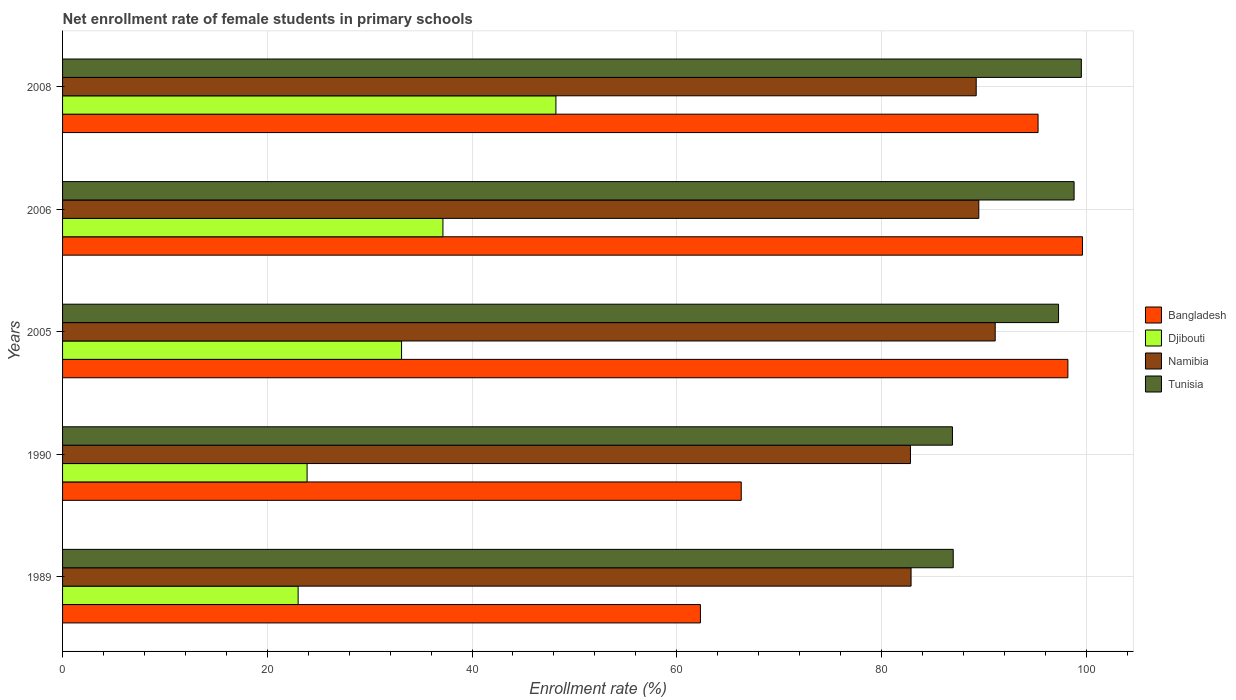How many different coloured bars are there?
Your answer should be very brief. 4. How many groups of bars are there?
Give a very brief answer. 5. Are the number of bars per tick equal to the number of legend labels?
Offer a very short reply. Yes. How many bars are there on the 4th tick from the bottom?
Give a very brief answer. 4. What is the net enrollment rate of female students in primary schools in Namibia in 2005?
Provide a succinct answer. 91.11. Across all years, what is the maximum net enrollment rate of female students in primary schools in Bangladesh?
Offer a terse response. 99.63. Across all years, what is the minimum net enrollment rate of female students in primary schools in Djibouti?
Provide a short and direct response. 23.01. What is the total net enrollment rate of female students in primary schools in Bangladesh in the graph?
Your answer should be compact. 421.75. What is the difference between the net enrollment rate of female students in primary schools in Djibouti in 1989 and that in 1990?
Offer a very short reply. -0.88. What is the difference between the net enrollment rate of female students in primary schools in Bangladesh in 2005 and the net enrollment rate of female students in primary schools in Namibia in 1989?
Keep it short and to the point. 15.32. What is the average net enrollment rate of female students in primary schools in Djibouti per year?
Your answer should be very brief. 33.07. In the year 2006, what is the difference between the net enrollment rate of female students in primary schools in Djibouti and net enrollment rate of female students in primary schools in Namibia?
Your response must be concise. -52.35. What is the ratio of the net enrollment rate of female students in primary schools in Tunisia in 2006 to that in 2008?
Keep it short and to the point. 0.99. What is the difference between the highest and the second highest net enrollment rate of female students in primary schools in Tunisia?
Your answer should be compact. 0.71. What is the difference between the highest and the lowest net enrollment rate of female students in primary schools in Bangladesh?
Make the answer very short. 37.32. In how many years, is the net enrollment rate of female students in primary schools in Djibouti greater than the average net enrollment rate of female students in primary schools in Djibouti taken over all years?
Your answer should be compact. 3. What does the 2nd bar from the top in 2006 represents?
Ensure brevity in your answer.  Namibia. What does the 2nd bar from the bottom in 2005 represents?
Give a very brief answer. Djibouti. Is it the case that in every year, the sum of the net enrollment rate of female students in primary schools in Namibia and net enrollment rate of female students in primary schools in Tunisia is greater than the net enrollment rate of female students in primary schools in Bangladesh?
Your response must be concise. Yes. Are all the bars in the graph horizontal?
Your answer should be compact. Yes. What is the difference between two consecutive major ticks on the X-axis?
Provide a succinct answer. 20. Does the graph contain grids?
Offer a very short reply. Yes. Where does the legend appear in the graph?
Your response must be concise. Center right. How are the legend labels stacked?
Give a very brief answer. Vertical. What is the title of the graph?
Provide a short and direct response. Net enrollment rate of female students in primary schools. Does "Angola" appear as one of the legend labels in the graph?
Ensure brevity in your answer.  No. What is the label or title of the X-axis?
Keep it short and to the point. Enrollment rate (%). What is the Enrollment rate (%) of Bangladesh in 1989?
Provide a succinct answer. 62.31. What is the Enrollment rate (%) of Djibouti in 1989?
Your answer should be compact. 23.01. What is the Enrollment rate (%) in Namibia in 1989?
Your answer should be very brief. 82.89. What is the Enrollment rate (%) in Tunisia in 1989?
Make the answer very short. 87.01. What is the Enrollment rate (%) of Bangladesh in 1990?
Offer a very short reply. 66.3. What is the Enrollment rate (%) of Djibouti in 1990?
Ensure brevity in your answer.  23.89. What is the Enrollment rate (%) in Namibia in 1990?
Provide a short and direct response. 82.83. What is the Enrollment rate (%) of Tunisia in 1990?
Offer a very short reply. 86.93. What is the Enrollment rate (%) in Bangladesh in 2005?
Give a very brief answer. 98.21. What is the Enrollment rate (%) of Djibouti in 2005?
Offer a very short reply. 33.12. What is the Enrollment rate (%) in Namibia in 2005?
Your answer should be very brief. 91.11. What is the Enrollment rate (%) of Tunisia in 2005?
Ensure brevity in your answer.  97.3. What is the Enrollment rate (%) of Bangladesh in 2006?
Keep it short and to the point. 99.63. What is the Enrollment rate (%) in Djibouti in 2006?
Your answer should be compact. 37.16. What is the Enrollment rate (%) in Namibia in 2006?
Make the answer very short. 89.51. What is the Enrollment rate (%) of Tunisia in 2006?
Your response must be concise. 98.81. What is the Enrollment rate (%) of Bangladesh in 2008?
Your answer should be compact. 95.29. What is the Enrollment rate (%) of Djibouti in 2008?
Your answer should be compact. 48.19. What is the Enrollment rate (%) in Namibia in 2008?
Your answer should be very brief. 89.25. What is the Enrollment rate (%) of Tunisia in 2008?
Your answer should be compact. 99.52. Across all years, what is the maximum Enrollment rate (%) of Bangladesh?
Keep it short and to the point. 99.63. Across all years, what is the maximum Enrollment rate (%) in Djibouti?
Give a very brief answer. 48.19. Across all years, what is the maximum Enrollment rate (%) in Namibia?
Your answer should be compact. 91.11. Across all years, what is the maximum Enrollment rate (%) in Tunisia?
Keep it short and to the point. 99.52. Across all years, what is the minimum Enrollment rate (%) of Bangladesh?
Your response must be concise. 62.31. Across all years, what is the minimum Enrollment rate (%) in Djibouti?
Ensure brevity in your answer.  23.01. Across all years, what is the minimum Enrollment rate (%) in Namibia?
Your answer should be compact. 82.83. Across all years, what is the minimum Enrollment rate (%) of Tunisia?
Your response must be concise. 86.93. What is the total Enrollment rate (%) in Bangladesh in the graph?
Keep it short and to the point. 421.75. What is the total Enrollment rate (%) in Djibouti in the graph?
Offer a terse response. 165.37. What is the total Enrollment rate (%) in Namibia in the graph?
Offer a terse response. 435.58. What is the total Enrollment rate (%) in Tunisia in the graph?
Ensure brevity in your answer.  469.57. What is the difference between the Enrollment rate (%) in Bangladesh in 1989 and that in 1990?
Your answer should be compact. -3.99. What is the difference between the Enrollment rate (%) in Djibouti in 1989 and that in 1990?
Your answer should be compact. -0.88. What is the difference between the Enrollment rate (%) of Namibia in 1989 and that in 1990?
Your answer should be compact. 0.06. What is the difference between the Enrollment rate (%) of Tunisia in 1989 and that in 1990?
Your answer should be compact. 0.08. What is the difference between the Enrollment rate (%) in Bangladesh in 1989 and that in 2005?
Provide a short and direct response. -35.9. What is the difference between the Enrollment rate (%) of Djibouti in 1989 and that in 2005?
Provide a succinct answer. -10.1. What is the difference between the Enrollment rate (%) of Namibia in 1989 and that in 2005?
Make the answer very short. -8.22. What is the difference between the Enrollment rate (%) of Tunisia in 1989 and that in 2005?
Make the answer very short. -10.29. What is the difference between the Enrollment rate (%) of Bangladesh in 1989 and that in 2006?
Your answer should be compact. -37.32. What is the difference between the Enrollment rate (%) of Djibouti in 1989 and that in 2006?
Your response must be concise. -14.15. What is the difference between the Enrollment rate (%) in Namibia in 1989 and that in 2006?
Your answer should be compact. -6.62. What is the difference between the Enrollment rate (%) of Tunisia in 1989 and that in 2006?
Offer a very short reply. -11.81. What is the difference between the Enrollment rate (%) in Bangladesh in 1989 and that in 2008?
Provide a succinct answer. -32.98. What is the difference between the Enrollment rate (%) in Djibouti in 1989 and that in 2008?
Provide a short and direct response. -25.18. What is the difference between the Enrollment rate (%) of Namibia in 1989 and that in 2008?
Your answer should be very brief. -6.36. What is the difference between the Enrollment rate (%) in Tunisia in 1989 and that in 2008?
Offer a terse response. -12.52. What is the difference between the Enrollment rate (%) of Bangladesh in 1990 and that in 2005?
Make the answer very short. -31.91. What is the difference between the Enrollment rate (%) of Djibouti in 1990 and that in 2005?
Provide a short and direct response. -9.23. What is the difference between the Enrollment rate (%) in Namibia in 1990 and that in 2005?
Your answer should be very brief. -8.28. What is the difference between the Enrollment rate (%) in Tunisia in 1990 and that in 2005?
Offer a terse response. -10.36. What is the difference between the Enrollment rate (%) of Bangladesh in 1990 and that in 2006?
Make the answer very short. -33.33. What is the difference between the Enrollment rate (%) of Djibouti in 1990 and that in 2006?
Your answer should be compact. -13.27. What is the difference between the Enrollment rate (%) of Namibia in 1990 and that in 2006?
Offer a very short reply. -6.68. What is the difference between the Enrollment rate (%) in Tunisia in 1990 and that in 2006?
Ensure brevity in your answer.  -11.88. What is the difference between the Enrollment rate (%) of Bangladesh in 1990 and that in 2008?
Provide a short and direct response. -28.99. What is the difference between the Enrollment rate (%) in Djibouti in 1990 and that in 2008?
Offer a very short reply. -24.31. What is the difference between the Enrollment rate (%) of Namibia in 1990 and that in 2008?
Give a very brief answer. -6.42. What is the difference between the Enrollment rate (%) in Tunisia in 1990 and that in 2008?
Offer a terse response. -12.59. What is the difference between the Enrollment rate (%) of Bangladesh in 2005 and that in 2006?
Keep it short and to the point. -1.42. What is the difference between the Enrollment rate (%) in Djibouti in 2005 and that in 2006?
Offer a very short reply. -4.04. What is the difference between the Enrollment rate (%) in Namibia in 2005 and that in 2006?
Provide a short and direct response. 1.6. What is the difference between the Enrollment rate (%) in Tunisia in 2005 and that in 2006?
Your answer should be compact. -1.52. What is the difference between the Enrollment rate (%) of Bangladesh in 2005 and that in 2008?
Make the answer very short. 2.92. What is the difference between the Enrollment rate (%) of Djibouti in 2005 and that in 2008?
Provide a short and direct response. -15.08. What is the difference between the Enrollment rate (%) in Namibia in 2005 and that in 2008?
Your answer should be compact. 1.86. What is the difference between the Enrollment rate (%) of Tunisia in 2005 and that in 2008?
Your answer should be very brief. -2.23. What is the difference between the Enrollment rate (%) in Bangladesh in 2006 and that in 2008?
Provide a succinct answer. 4.34. What is the difference between the Enrollment rate (%) of Djibouti in 2006 and that in 2008?
Offer a very short reply. -11.04. What is the difference between the Enrollment rate (%) of Namibia in 2006 and that in 2008?
Your answer should be very brief. 0.25. What is the difference between the Enrollment rate (%) of Tunisia in 2006 and that in 2008?
Make the answer very short. -0.71. What is the difference between the Enrollment rate (%) in Bangladesh in 1989 and the Enrollment rate (%) in Djibouti in 1990?
Offer a very short reply. 38.42. What is the difference between the Enrollment rate (%) in Bangladesh in 1989 and the Enrollment rate (%) in Namibia in 1990?
Your answer should be compact. -20.52. What is the difference between the Enrollment rate (%) of Bangladesh in 1989 and the Enrollment rate (%) of Tunisia in 1990?
Your response must be concise. -24.62. What is the difference between the Enrollment rate (%) of Djibouti in 1989 and the Enrollment rate (%) of Namibia in 1990?
Offer a terse response. -59.82. What is the difference between the Enrollment rate (%) in Djibouti in 1989 and the Enrollment rate (%) in Tunisia in 1990?
Your response must be concise. -63.92. What is the difference between the Enrollment rate (%) of Namibia in 1989 and the Enrollment rate (%) of Tunisia in 1990?
Your response must be concise. -4.04. What is the difference between the Enrollment rate (%) in Bangladesh in 1989 and the Enrollment rate (%) in Djibouti in 2005?
Provide a succinct answer. 29.19. What is the difference between the Enrollment rate (%) of Bangladesh in 1989 and the Enrollment rate (%) of Namibia in 2005?
Offer a very short reply. -28.8. What is the difference between the Enrollment rate (%) in Bangladesh in 1989 and the Enrollment rate (%) in Tunisia in 2005?
Give a very brief answer. -34.98. What is the difference between the Enrollment rate (%) in Djibouti in 1989 and the Enrollment rate (%) in Namibia in 2005?
Offer a very short reply. -68.09. What is the difference between the Enrollment rate (%) in Djibouti in 1989 and the Enrollment rate (%) in Tunisia in 2005?
Your response must be concise. -74.28. What is the difference between the Enrollment rate (%) in Namibia in 1989 and the Enrollment rate (%) in Tunisia in 2005?
Offer a very short reply. -14.41. What is the difference between the Enrollment rate (%) in Bangladesh in 1989 and the Enrollment rate (%) in Djibouti in 2006?
Provide a succinct answer. 25.15. What is the difference between the Enrollment rate (%) of Bangladesh in 1989 and the Enrollment rate (%) of Namibia in 2006?
Your answer should be very brief. -27.2. What is the difference between the Enrollment rate (%) of Bangladesh in 1989 and the Enrollment rate (%) of Tunisia in 2006?
Keep it short and to the point. -36.5. What is the difference between the Enrollment rate (%) of Djibouti in 1989 and the Enrollment rate (%) of Namibia in 2006?
Offer a terse response. -66.49. What is the difference between the Enrollment rate (%) of Djibouti in 1989 and the Enrollment rate (%) of Tunisia in 2006?
Make the answer very short. -75.8. What is the difference between the Enrollment rate (%) in Namibia in 1989 and the Enrollment rate (%) in Tunisia in 2006?
Your response must be concise. -15.93. What is the difference between the Enrollment rate (%) of Bangladesh in 1989 and the Enrollment rate (%) of Djibouti in 2008?
Keep it short and to the point. 14.12. What is the difference between the Enrollment rate (%) of Bangladesh in 1989 and the Enrollment rate (%) of Namibia in 2008?
Your answer should be very brief. -26.94. What is the difference between the Enrollment rate (%) in Bangladesh in 1989 and the Enrollment rate (%) in Tunisia in 2008?
Your answer should be compact. -37.21. What is the difference between the Enrollment rate (%) in Djibouti in 1989 and the Enrollment rate (%) in Namibia in 2008?
Keep it short and to the point. -66.24. What is the difference between the Enrollment rate (%) in Djibouti in 1989 and the Enrollment rate (%) in Tunisia in 2008?
Keep it short and to the point. -76.51. What is the difference between the Enrollment rate (%) of Namibia in 1989 and the Enrollment rate (%) of Tunisia in 2008?
Offer a terse response. -16.64. What is the difference between the Enrollment rate (%) in Bangladesh in 1990 and the Enrollment rate (%) in Djibouti in 2005?
Offer a terse response. 33.18. What is the difference between the Enrollment rate (%) of Bangladesh in 1990 and the Enrollment rate (%) of Namibia in 2005?
Give a very brief answer. -24.81. What is the difference between the Enrollment rate (%) in Bangladesh in 1990 and the Enrollment rate (%) in Tunisia in 2005?
Your response must be concise. -31. What is the difference between the Enrollment rate (%) in Djibouti in 1990 and the Enrollment rate (%) in Namibia in 2005?
Your answer should be compact. -67.22. What is the difference between the Enrollment rate (%) of Djibouti in 1990 and the Enrollment rate (%) of Tunisia in 2005?
Give a very brief answer. -73.41. What is the difference between the Enrollment rate (%) of Namibia in 1990 and the Enrollment rate (%) of Tunisia in 2005?
Offer a terse response. -14.47. What is the difference between the Enrollment rate (%) of Bangladesh in 1990 and the Enrollment rate (%) of Djibouti in 2006?
Your response must be concise. 29.14. What is the difference between the Enrollment rate (%) of Bangladesh in 1990 and the Enrollment rate (%) of Namibia in 2006?
Make the answer very short. -23.21. What is the difference between the Enrollment rate (%) of Bangladesh in 1990 and the Enrollment rate (%) of Tunisia in 2006?
Give a very brief answer. -32.51. What is the difference between the Enrollment rate (%) in Djibouti in 1990 and the Enrollment rate (%) in Namibia in 2006?
Provide a short and direct response. -65.62. What is the difference between the Enrollment rate (%) in Djibouti in 1990 and the Enrollment rate (%) in Tunisia in 2006?
Provide a short and direct response. -74.93. What is the difference between the Enrollment rate (%) of Namibia in 1990 and the Enrollment rate (%) of Tunisia in 2006?
Your response must be concise. -15.99. What is the difference between the Enrollment rate (%) in Bangladesh in 1990 and the Enrollment rate (%) in Djibouti in 2008?
Offer a terse response. 18.1. What is the difference between the Enrollment rate (%) in Bangladesh in 1990 and the Enrollment rate (%) in Namibia in 2008?
Your answer should be compact. -22.95. What is the difference between the Enrollment rate (%) of Bangladesh in 1990 and the Enrollment rate (%) of Tunisia in 2008?
Make the answer very short. -33.22. What is the difference between the Enrollment rate (%) of Djibouti in 1990 and the Enrollment rate (%) of Namibia in 2008?
Offer a very short reply. -65.36. What is the difference between the Enrollment rate (%) in Djibouti in 1990 and the Enrollment rate (%) in Tunisia in 2008?
Offer a terse response. -75.64. What is the difference between the Enrollment rate (%) in Namibia in 1990 and the Enrollment rate (%) in Tunisia in 2008?
Your response must be concise. -16.69. What is the difference between the Enrollment rate (%) in Bangladesh in 2005 and the Enrollment rate (%) in Djibouti in 2006?
Ensure brevity in your answer.  61.05. What is the difference between the Enrollment rate (%) in Bangladesh in 2005 and the Enrollment rate (%) in Namibia in 2006?
Give a very brief answer. 8.7. What is the difference between the Enrollment rate (%) of Bangladesh in 2005 and the Enrollment rate (%) of Tunisia in 2006?
Provide a succinct answer. -0.61. What is the difference between the Enrollment rate (%) of Djibouti in 2005 and the Enrollment rate (%) of Namibia in 2006?
Offer a terse response. -56.39. What is the difference between the Enrollment rate (%) of Djibouti in 2005 and the Enrollment rate (%) of Tunisia in 2006?
Make the answer very short. -65.7. What is the difference between the Enrollment rate (%) in Namibia in 2005 and the Enrollment rate (%) in Tunisia in 2006?
Your answer should be very brief. -7.71. What is the difference between the Enrollment rate (%) of Bangladesh in 2005 and the Enrollment rate (%) of Djibouti in 2008?
Provide a succinct answer. 50.01. What is the difference between the Enrollment rate (%) in Bangladesh in 2005 and the Enrollment rate (%) in Namibia in 2008?
Your response must be concise. 8.96. What is the difference between the Enrollment rate (%) of Bangladesh in 2005 and the Enrollment rate (%) of Tunisia in 2008?
Keep it short and to the point. -1.31. What is the difference between the Enrollment rate (%) in Djibouti in 2005 and the Enrollment rate (%) in Namibia in 2008?
Provide a short and direct response. -56.14. What is the difference between the Enrollment rate (%) in Djibouti in 2005 and the Enrollment rate (%) in Tunisia in 2008?
Your answer should be compact. -66.41. What is the difference between the Enrollment rate (%) in Namibia in 2005 and the Enrollment rate (%) in Tunisia in 2008?
Keep it short and to the point. -8.42. What is the difference between the Enrollment rate (%) of Bangladesh in 2006 and the Enrollment rate (%) of Djibouti in 2008?
Your answer should be compact. 51.44. What is the difference between the Enrollment rate (%) in Bangladesh in 2006 and the Enrollment rate (%) in Namibia in 2008?
Your answer should be compact. 10.38. What is the difference between the Enrollment rate (%) in Bangladesh in 2006 and the Enrollment rate (%) in Tunisia in 2008?
Ensure brevity in your answer.  0.11. What is the difference between the Enrollment rate (%) of Djibouti in 2006 and the Enrollment rate (%) of Namibia in 2008?
Ensure brevity in your answer.  -52.09. What is the difference between the Enrollment rate (%) of Djibouti in 2006 and the Enrollment rate (%) of Tunisia in 2008?
Your answer should be compact. -62.37. What is the difference between the Enrollment rate (%) of Namibia in 2006 and the Enrollment rate (%) of Tunisia in 2008?
Make the answer very short. -10.02. What is the average Enrollment rate (%) in Bangladesh per year?
Your answer should be very brief. 84.35. What is the average Enrollment rate (%) of Djibouti per year?
Give a very brief answer. 33.07. What is the average Enrollment rate (%) of Namibia per year?
Keep it short and to the point. 87.12. What is the average Enrollment rate (%) of Tunisia per year?
Keep it short and to the point. 93.91. In the year 1989, what is the difference between the Enrollment rate (%) of Bangladesh and Enrollment rate (%) of Djibouti?
Your answer should be compact. 39.3. In the year 1989, what is the difference between the Enrollment rate (%) of Bangladesh and Enrollment rate (%) of Namibia?
Provide a succinct answer. -20.58. In the year 1989, what is the difference between the Enrollment rate (%) of Bangladesh and Enrollment rate (%) of Tunisia?
Provide a short and direct response. -24.7. In the year 1989, what is the difference between the Enrollment rate (%) in Djibouti and Enrollment rate (%) in Namibia?
Offer a very short reply. -59.88. In the year 1989, what is the difference between the Enrollment rate (%) of Djibouti and Enrollment rate (%) of Tunisia?
Your answer should be very brief. -64. In the year 1989, what is the difference between the Enrollment rate (%) of Namibia and Enrollment rate (%) of Tunisia?
Offer a very short reply. -4.12. In the year 1990, what is the difference between the Enrollment rate (%) in Bangladesh and Enrollment rate (%) in Djibouti?
Provide a succinct answer. 42.41. In the year 1990, what is the difference between the Enrollment rate (%) in Bangladesh and Enrollment rate (%) in Namibia?
Offer a very short reply. -16.53. In the year 1990, what is the difference between the Enrollment rate (%) in Bangladesh and Enrollment rate (%) in Tunisia?
Keep it short and to the point. -20.63. In the year 1990, what is the difference between the Enrollment rate (%) of Djibouti and Enrollment rate (%) of Namibia?
Provide a short and direct response. -58.94. In the year 1990, what is the difference between the Enrollment rate (%) of Djibouti and Enrollment rate (%) of Tunisia?
Give a very brief answer. -63.04. In the year 1990, what is the difference between the Enrollment rate (%) of Namibia and Enrollment rate (%) of Tunisia?
Provide a short and direct response. -4.1. In the year 2005, what is the difference between the Enrollment rate (%) of Bangladesh and Enrollment rate (%) of Djibouti?
Your answer should be very brief. 65.09. In the year 2005, what is the difference between the Enrollment rate (%) of Bangladesh and Enrollment rate (%) of Namibia?
Offer a very short reply. 7.1. In the year 2005, what is the difference between the Enrollment rate (%) in Bangladesh and Enrollment rate (%) in Tunisia?
Your answer should be compact. 0.91. In the year 2005, what is the difference between the Enrollment rate (%) in Djibouti and Enrollment rate (%) in Namibia?
Offer a terse response. -57.99. In the year 2005, what is the difference between the Enrollment rate (%) of Djibouti and Enrollment rate (%) of Tunisia?
Offer a very short reply. -64.18. In the year 2005, what is the difference between the Enrollment rate (%) of Namibia and Enrollment rate (%) of Tunisia?
Provide a succinct answer. -6.19. In the year 2006, what is the difference between the Enrollment rate (%) in Bangladesh and Enrollment rate (%) in Djibouti?
Make the answer very short. 62.47. In the year 2006, what is the difference between the Enrollment rate (%) in Bangladesh and Enrollment rate (%) in Namibia?
Your response must be concise. 10.13. In the year 2006, what is the difference between the Enrollment rate (%) of Bangladesh and Enrollment rate (%) of Tunisia?
Your answer should be compact. 0.82. In the year 2006, what is the difference between the Enrollment rate (%) of Djibouti and Enrollment rate (%) of Namibia?
Provide a succinct answer. -52.35. In the year 2006, what is the difference between the Enrollment rate (%) in Djibouti and Enrollment rate (%) in Tunisia?
Your response must be concise. -61.66. In the year 2006, what is the difference between the Enrollment rate (%) in Namibia and Enrollment rate (%) in Tunisia?
Your answer should be very brief. -9.31. In the year 2008, what is the difference between the Enrollment rate (%) of Bangladesh and Enrollment rate (%) of Djibouti?
Your answer should be very brief. 47.1. In the year 2008, what is the difference between the Enrollment rate (%) in Bangladesh and Enrollment rate (%) in Namibia?
Your answer should be compact. 6.04. In the year 2008, what is the difference between the Enrollment rate (%) of Bangladesh and Enrollment rate (%) of Tunisia?
Offer a very short reply. -4.23. In the year 2008, what is the difference between the Enrollment rate (%) of Djibouti and Enrollment rate (%) of Namibia?
Your answer should be compact. -41.06. In the year 2008, what is the difference between the Enrollment rate (%) of Djibouti and Enrollment rate (%) of Tunisia?
Offer a very short reply. -51.33. In the year 2008, what is the difference between the Enrollment rate (%) of Namibia and Enrollment rate (%) of Tunisia?
Provide a short and direct response. -10.27. What is the ratio of the Enrollment rate (%) in Bangladesh in 1989 to that in 1990?
Provide a succinct answer. 0.94. What is the ratio of the Enrollment rate (%) of Djibouti in 1989 to that in 1990?
Make the answer very short. 0.96. What is the ratio of the Enrollment rate (%) in Tunisia in 1989 to that in 1990?
Provide a succinct answer. 1. What is the ratio of the Enrollment rate (%) of Bangladesh in 1989 to that in 2005?
Provide a succinct answer. 0.63. What is the ratio of the Enrollment rate (%) of Djibouti in 1989 to that in 2005?
Provide a succinct answer. 0.69. What is the ratio of the Enrollment rate (%) of Namibia in 1989 to that in 2005?
Keep it short and to the point. 0.91. What is the ratio of the Enrollment rate (%) of Tunisia in 1989 to that in 2005?
Make the answer very short. 0.89. What is the ratio of the Enrollment rate (%) in Bangladesh in 1989 to that in 2006?
Your answer should be very brief. 0.63. What is the ratio of the Enrollment rate (%) in Djibouti in 1989 to that in 2006?
Ensure brevity in your answer.  0.62. What is the ratio of the Enrollment rate (%) of Namibia in 1989 to that in 2006?
Make the answer very short. 0.93. What is the ratio of the Enrollment rate (%) of Tunisia in 1989 to that in 2006?
Your answer should be very brief. 0.88. What is the ratio of the Enrollment rate (%) in Bangladesh in 1989 to that in 2008?
Make the answer very short. 0.65. What is the ratio of the Enrollment rate (%) of Djibouti in 1989 to that in 2008?
Give a very brief answer. 0.48. What is the ratio of the Enrollment rate (%) in Namibia in 1989 to that in 2008?
Offer a terse response. 0.93. What is the ratio of the Enrollment rate (%) in Tunisia in 1989 to that in 2008?
Make the answer very short. 0.87. What is the ratio of the Enrollment rate (%) of Bangladesh in 1990 to that in 2005?
Offer a terse response. 0.68. What is the ratio of the Enrollment rate (%) of Djibouti in 1990 to that in 2005?
Your answer should be compact. 0.72. What is the ratio of the Enrollment rate (%) in Namibia in 1990 to that in 2005?
Offer a very short reply. 0.91. What is the ratio of the Enrollment rate (%) in Tunisia in 1990 to that in 2005?
Give a very brief answer. 0.89. What is the ratio of the Enrollment rate (%) in Bangladesh in 1990 to that in 2006?
Your answer should be compact. 0.67. What is the ratio of the Enrollment rate (%) in Djibouti in 1990 to that in 2006?
Provide a short and direct response. 0.64. What is the ratio of the Enrollment rate (%) of Namibia in 1990 to that in 2006?
Keep it short and to the point. 0.93. What is the ratio of the Enrollment rate (%) in Tunisia in 1990 to that in 2006?
Ensure brevity in your answer.  0.88. What is the ratio of the Enrollment rate (%) in Bangladesh in 1990 to that in 2008?
Offer a very short reply. 0.7. What is the ratio of the Enrollment rate (%) in Djibouti in 1990 to that in 2008?
Provide a succinct answer. 0.5. What is the ratio of the Enrollment rate (%) of Namibia in 1990 to that in 2008?
Give a very brief answer. 0.93. What is the ratio of the Enrollment rate (%) in Tunisia in 1990 to that in 2008?
Make the answer very short. 0.87. What is the ratio of the Enrollment rate (%) of Bangladesh in 2005 to that in 2006?
Give a very brief answer. 0.99. What is the ratio of the Enrollment rate (%) of Djibouti in 2005 to that in 2006?
Provide a short and direct response. 0.89. What is the ratio of the Enrollment rate (%) in Namibia in 2005 to that in 2006?
Provide a succinct answer. 1.02. What is the ratio of the Enrollment rate (%) of Tunisia in 2005 to that in 2006?
Ensure brevity in your answer.  0.98. What is the ratio of the Enrollment rate (%) in Bangladesh in 2005 to that in 2008?
Provide a succinct answer. 1.03. What is the ratio of the Enrollment rate (%) of Djibouti in 2005 to that in 2008?
Make the answer very short. 0.69. What is the ratio of the Enrollment rate (%) in Namibia in 2005 to that in 2008?
Your answer should be compact. 1.02. What is the ratio of the Enrollment rate (%) in Tunisia in 2005 to that in 2008?
Give a very brief answer. 0.98. What is the ratio of the Enrollment rate (%) in Bangladesh in 2006 to that in 2008?
Offer a very short reply. 1.05. What is the ratio of the Enrollment rate (%) in Djibouti in 2006 to that in 2008?
Make the answer very short. 0.77. What is the difference between the highest and the second highest Enrollment rate (%) of Bangladesh?
Give a very brief answer. 1.42. What is the difference between the highest and the second highest Enrollment rate (%) of Djibouti?
Your response must be concise. 11.04. What is the difference between the highest and the second highest Enrollment rate (%) in Namibia?
Keep it short and to the point. 1.6. What is the difference between the highest and the second highest Enrollment rate (%) of Tunisia?
Your answer should be very brief. 0.71. What is the difference between the highest and the lowest Enrollment rate (%) of Bangladesh?
Your response must be concise. 37.32. What is the difference between the highest and the lowest Enrollment rate (%) in Djibouti?
Make the answer very short. 25.18. What is the difference between the highest and the lowest Enrollment rate (%) in Namibia?
Ensure brevity in your answer.  8.28. What is the difference between the highest and the lowest Enrollment rate (%) of Tunisia?
Offer a terse response. 12.59. 